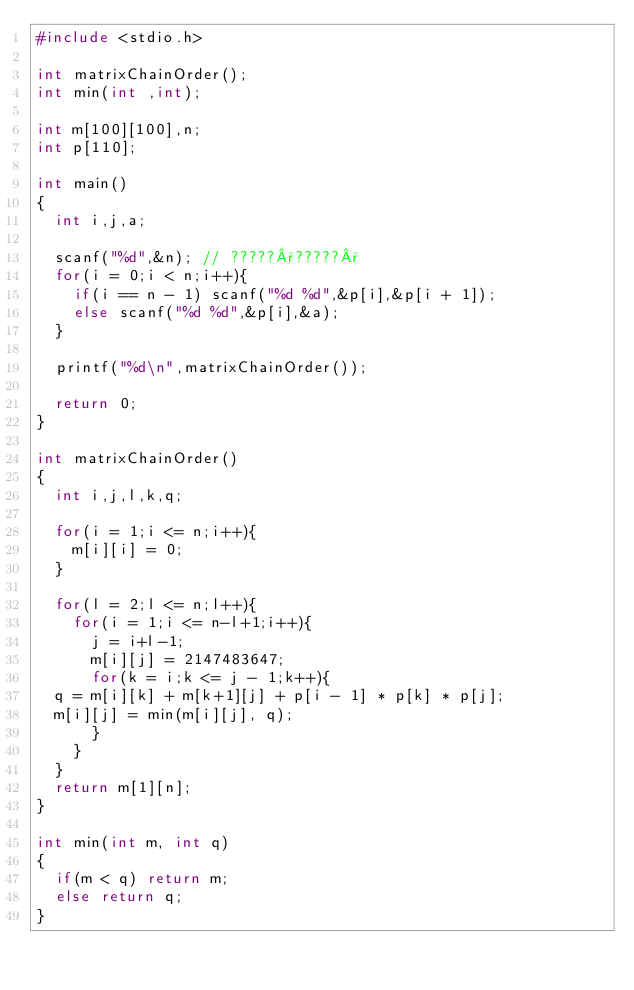<code> <loc_0><loc_0><loc_500><loc_500><_C_>#include <stdio.h>

int matrixChainOrder();
int min(int ,int); 

int m[100][100],n;
int p[110];

int main()
{
  int i,j,a;

  scanf("%d",&n); // ?????°?????°
  for(i = 0;i < n;i++){
    if(i == n - 1) scanf("%d %d",&p[i],&p[i + 1]);
    else scanf("%d %d",&p[i],&a);
  }

  printf("%d\n",matrixChainOrder());

  return 0;
}

int matrixChainOrder()
{
  int i,j,l,k,q;

  for(i = 1;i <= n;i++){
    m[i][i] = 0;
  }

  for(l = 2;l <= n;l++){
    for(i = 1;i <= n-l+1;i++){
      j = i+l-1;
      m[i][j] = 2147483647;
      for(k = i;k <= j - 1;k++){
	q = m[i][k] + m[k+1][j] + p[i - 1] * p[k] * p[j];
	m[i][j] = min(m[i][j], q);
      }
    }
  }
  return m[1][n];
}

int min(int m, int q)
{
  if(m < q) return m;
  else return q;
}</code> 